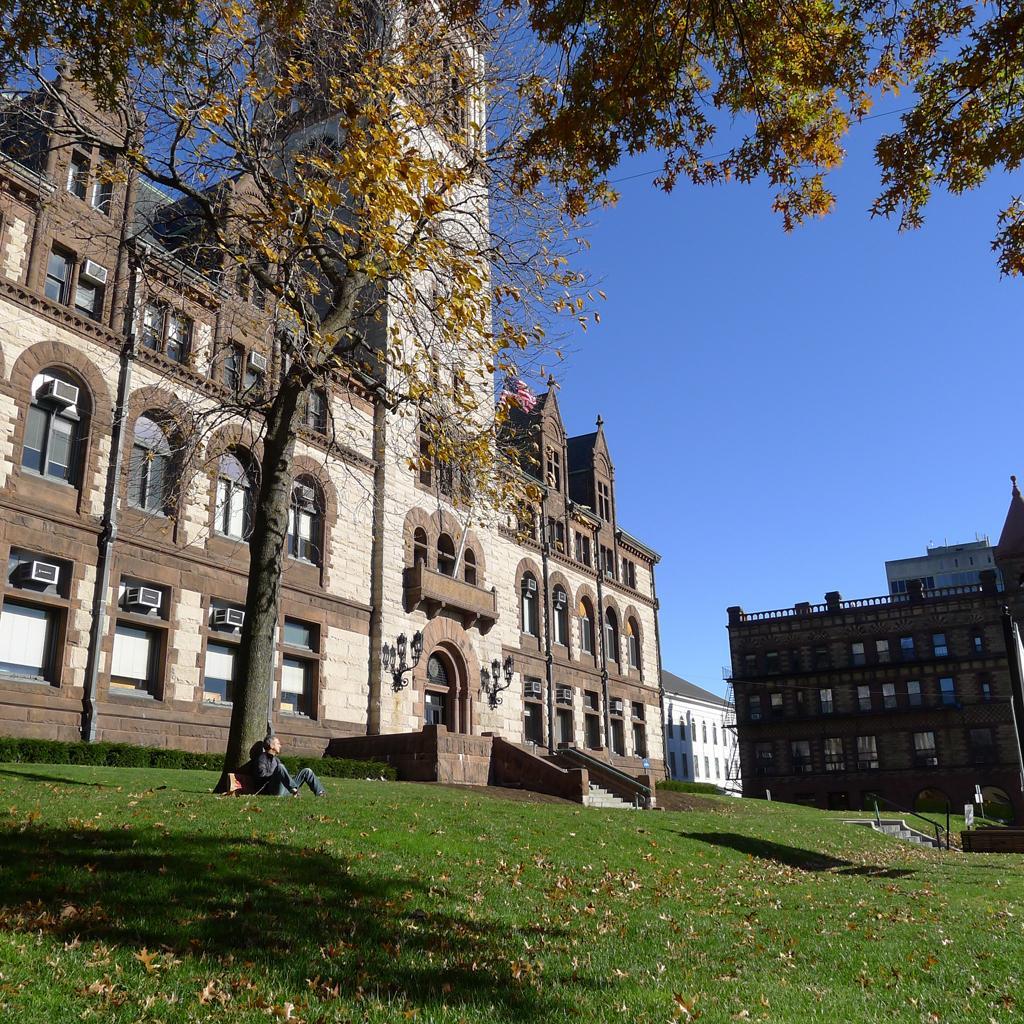Describe this image in one or two sentences. In this picture I can see a person sitting, there is grass, there are trees, lights, buildings, air conditioners, and in the background there is sky. 